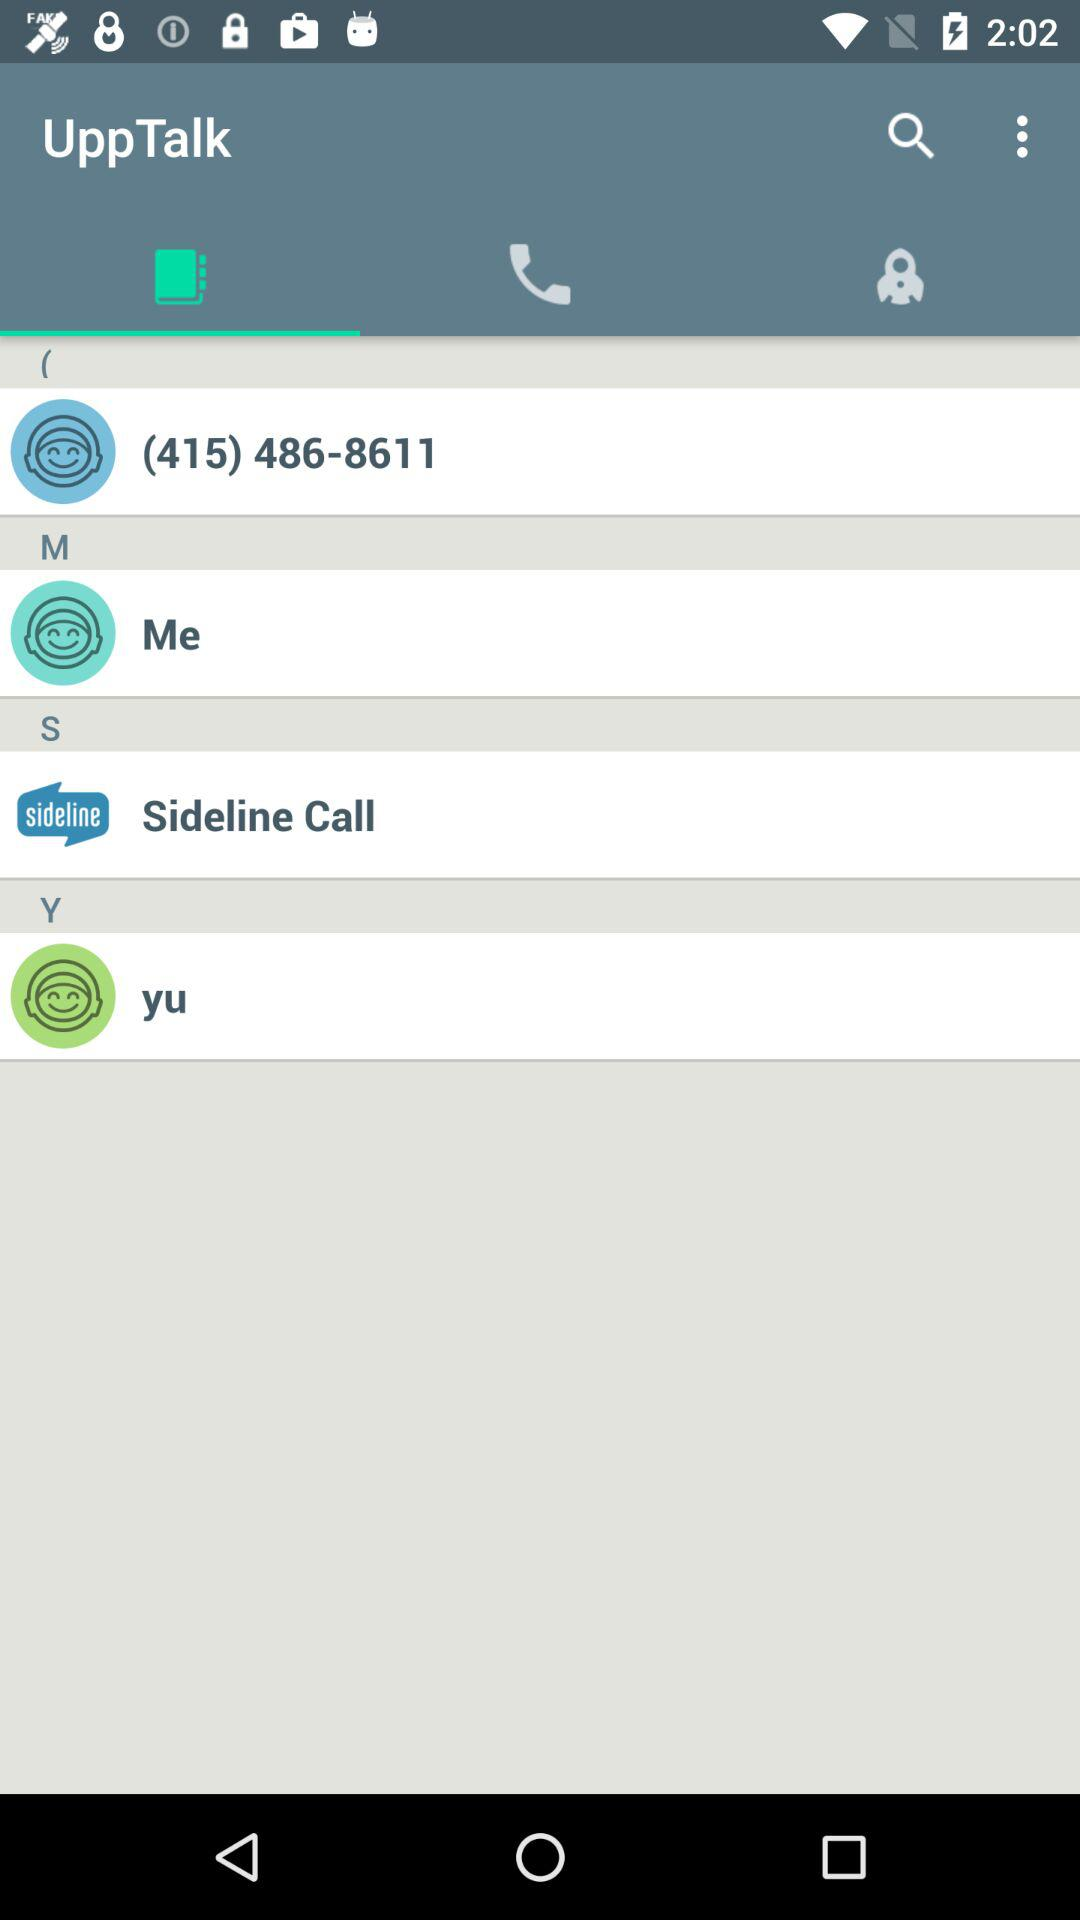What is the name of the application? The name of the application is "UppTalk". 